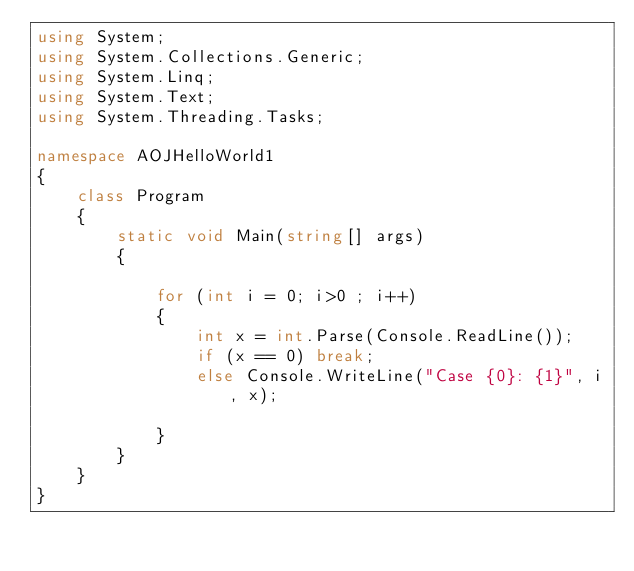<code> <loc_0><loc_0><loc_500><loc_500><_C#_>using System;
using System.Collections.Generic;
using System.Linq;
using System.Text;
using System.Threading.Tasks;

namespace AOJHelloWorld1
{
    class Program
    {
        static void Main(string[] args)
        {

            for (int i = 0; i>0 ; i++)
            {
                int x = int.Parse(Console.ReadLine());
                if (x == 0) break;
                else Console.WriteLine("Case {0}: {1}", i, x);

            }
        }
    }
}
</code> 